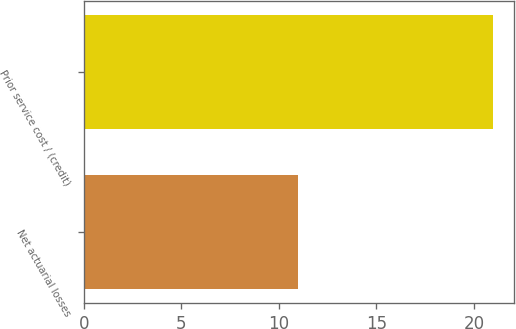Convert chart to OTSL. <chart><loc_0><loc_0><loc_500><loc_500><bar_chart><fcel>Net actuarial losses<fcel>Prior service cost / (credit)<nl><fcel>11<fcel>21<nl></chart> 